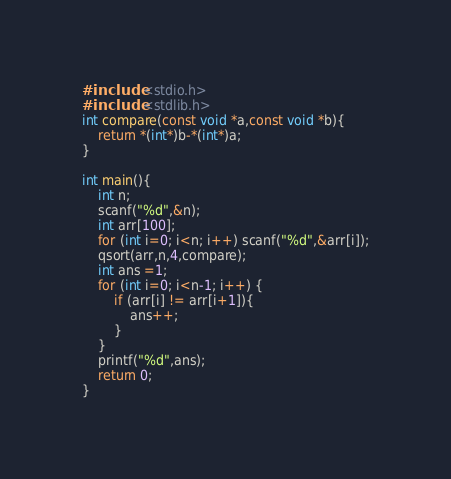<code> <loc_0><loc_0><loc_500><loc_500><_C_>#include <stdio.h>
#include <stdlib.h>
int compare(const void *a,const void *b){
    return *(int*)b-*(int*)a;
}

int main(){
    int n;
    scanf("%d",&n);
    int arr[100];
    for (int i=0; i<n; i++) scanf("%d",&arr[i]);
    qsort(arr,n,4,compare);
    int ans =1;
    for (int i=0; i<n-1; i++) {
        if (arr[i] != arr[i+1]){
            ans++;
        }
    }
    printf("%d",ans);
    return 0;
}</code> 